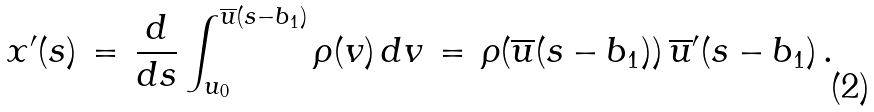<formula> <loc_0><loc_0><loc_500><loc_500>x ^ { \prime } ( s ) \, = \, \frac { d } { d s } \int _ { u _ { 0 } } ^ { \overline { u } ( s - b _ { 1 } ) } \rho ( v ) \, d v \, = \, \rho ( \overline { u } ( s - b _ { 1 } ) ) \, \overline { u } ^ { \prime } ( s - b _ { 1 } ) \, .</formula> 